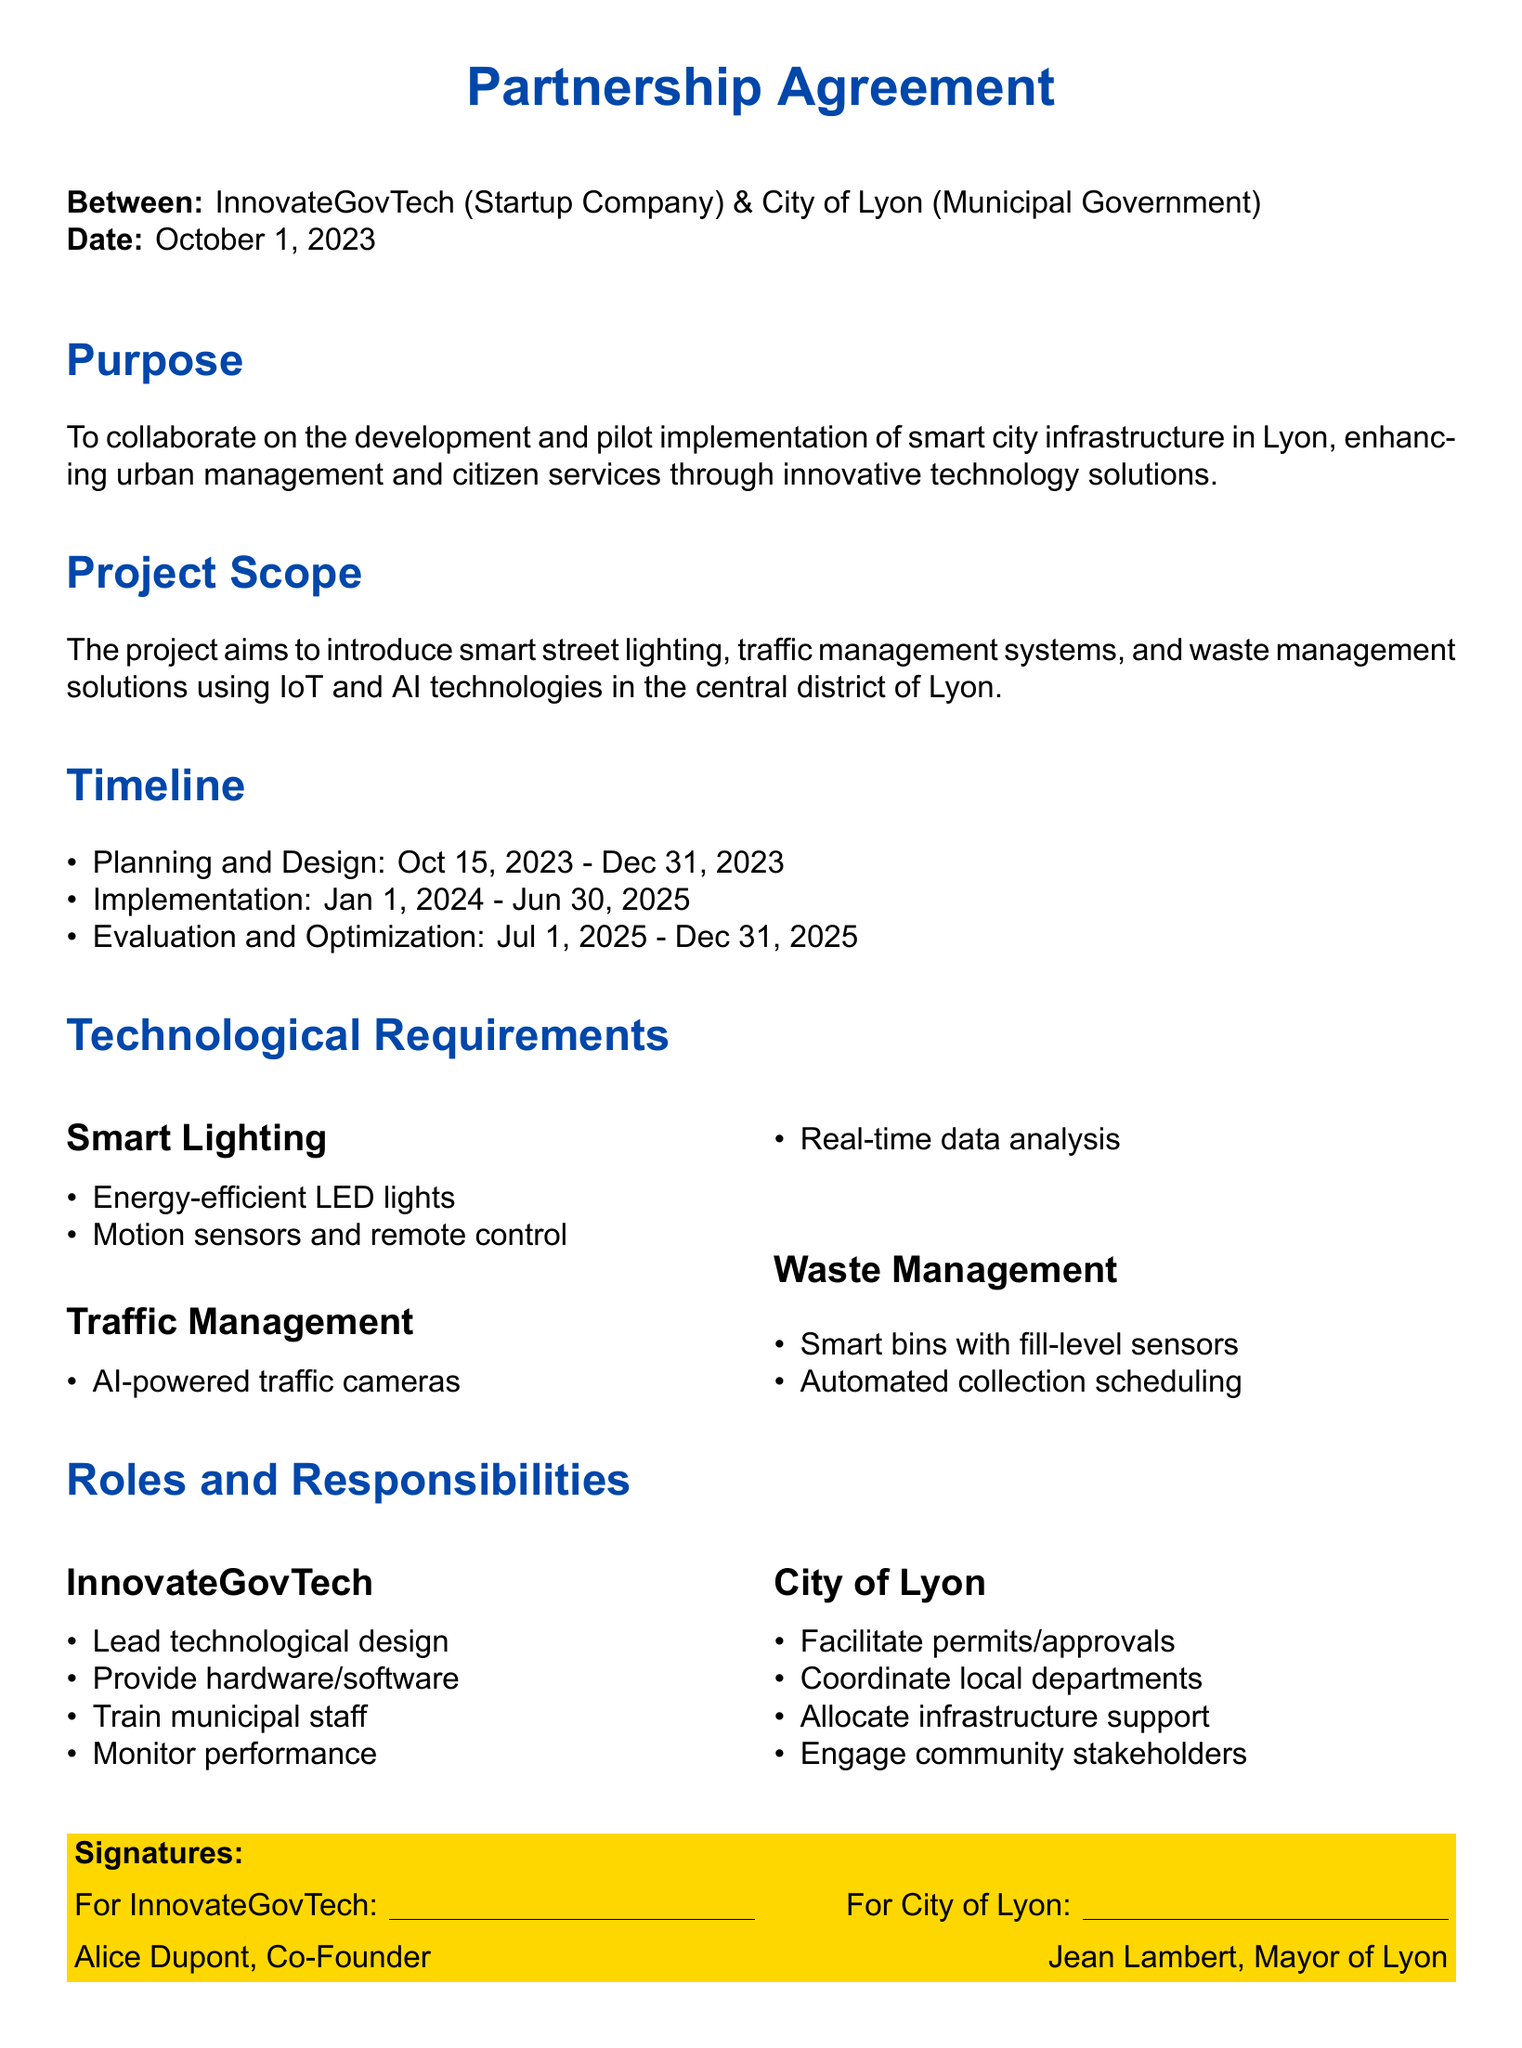What is the purpose of the partnership agreement? The purpose of the partnership agreement is outlined in the document as a collaboration on developing and pilot implementing smart city infrastructure in Lyon.
Answer: To collaborate on the development and pilot implementation of smart city infrastructure in Lyon What is the start date of the planning phase? The planning phase begins on October 15, 2023, as indicated in the timeline section of the document.
Answer: October 15, 2023 What technology will be used for waste management? The document specifies 'smart bins with fill-level sensors' as part of the technological requirements for waste management.
Answer: Smart bins with fill-level sensors What does InnovateGovTech provide? InnovateGovTech is responsible for providing hardware/software according to the roles and responsibilities section.
Answer: Hardware/software What is the end date for implementation? The document states that implementation will conclude on June 30, 2025, detailing the project's timeline.
Answer: June 30, 2025 Who is the co-founder of InnovateGovTech? The document states that Alice Dupont is the co-founder of InnovateGovTech, as listed in the signatures section.
Answer: Alice Dupont What role does the City of Lyon play in facilitating the project? According to the roles and responsibilities, the City of Lyon facilitates permits/approvals for the project.
Answer: Facilitate permits/approvals During which phase will evaluation and optimization occur? The evaluation and optimization phase takes place from July 1, 2025, to December 31, 2025, as outlined in the timeline section.
Answer: July 1, 2025 - December 31, 2025 What is the name of the mayor of Lyon? The signatures section of the document names Jean Lambert as the mayor of Lyon.
Answer: Jean Lambert 